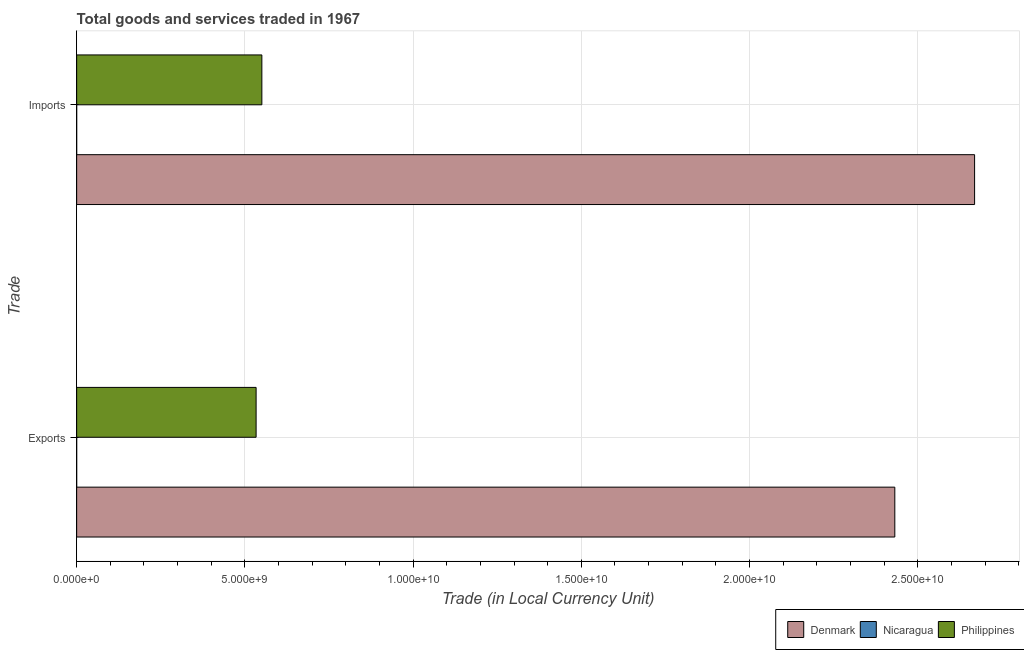How many different coloured bars are there?
Offer a very short reply. 3. Are the number of bars per tick equal to the number of legend labels?
Give a very brief answer. Yes. What is the label of the 1st group of bars from the top?
Make the answer very short. Imports. What is the export of goods and services in Philippines?
Your response must be concise. 5.33e+09. Across all countries, what is the maximum export of goods and services?
Make the answer very short. 2.43e+1. Across all countries, what is the minimum export of goods and services?
Make the answer very short. 0.24. In which country was the imports of goods and services minimum?
Provide a succinct answer. Nicaragua. What is the total imports of goods and services in the graph?
Your answer should be compact. 3.22e+1. What is the difference between the export of goods and services in Denmark and that in Philippines?
Make the answer very short. 1.90e+1. What is the difference between the export of goods and services in Denmark and the imports of goods and services in Philippines?
Make the answer very short. 1.88e+1. What is the average imports of goods and services per country?
Give a very brief answer. 1.07e+1. What is the difference between the export of goods and services and imports of goods and services in Philippines?
Make the answer very short. -1.71e+08. What is the ratio of the export of goods and services in Denmark to that in Philippines?
Give a very brief answer. 4.56. Is the export of goods and services in Denmark less than that in Nicaragua?
Make the answer very short. No. What does the 1st bar from the top in Exports represents?
Provide a succinct answer. Philippines. What does the 3rd bar from the bottom in Exports represents?
Your answer should be very brief. Philippines. Are all the bars in the graph horizontal?
Give a very brief answer. Yes. What is the difference between two consecutive major ticks on the X-axis?
Offer a terse response. 5.00e+09. Are the values on the major ticks of X-axis written in scientific E-notation?
Make the answer very short. Yes. Where does the legend appear in the graph?
Give a very brief answer. Bottom right. How many legend labels are there?
Ensure brevity in your answer.  3. How are the legend labels stacked?
Provide a succinct answer. Horizontal. What is the title of the graph?
Your answer should be compact. Total goods and services traded in 1967. Does "Benin" appear as one of the legend labels in the graph?
Keep it short and to the point. No. What is the label or title of the X-axis?
Provide a short and direct response. Trade (in Local Currency Unit). What is the label or title of the Y-axis?
Provide a succinct answer. Trade. What is the Trade (in Local Currency Unit) of Denmark in Exports?
Your answer should be very brief. 2.43e+1. What is the Trade (in Local Currency Unit) of Nicaragua in Exports?
Offer a very short reply. 0.24. What is the Trade (in Local Currency Unit) of Philippines in Exports?
Ensure brevity in your answer.  5.33e+09. What is the Trade (in Local Currency Unit) of Denmark in Imports?
Offer a very short reply. 2.67e+1. What is the Trade (in Local Currency Unit) in Nicaragua in Imports?
Your answer should be very brief. 0.32. What is the Trade (in Local Currency Unit) of Philippines in Imports?
Ensure brevity in your answer.  5.50e+09. Across all Trade, what is the maximum Trade (in Local Currency Unit) in Denmark?
Your answer should be compact. 2.67e+1. Across all Trade, what is the maximum Trade (in Local Currency Unit) of Nicaragua?
Your answer should be very brief. 0.32. Across all Trade, what is the maximum Trade (in Local Currency Unit) of Philippines?
Provide a succinct answer. 5.50e+09. Across all Trade, what is the minimum Trade (in Local Currency Unit) of Denmark?
Give a very brief answer. 2.43e+1. Across all Trade, what is the minimum Trade (in Local Currency Unit) of Nicaragua?
Your response must be concise. 0.24. Across all Trade, what is the minimum Trade (in Local Currency Unit) of Philippines?
Ensure brevity in your answer.  5.33e+09. What is the total Trade (in Local Currency Unit) in Denmark in the graph?
Offer a very short reply. 5.10e+1. What is the total Trade (in Local Currency Unit) in Nicaragua in the graph?
Offer a very short reply. 0.57. What is the total Trade (in Local Currency Unit) in Philippines in the graph?
Give a very brief answer. 1.08e+1. What is the difference between the Trade (in Local Currency Unit) of Denmark in Exports and that in Imports?
Keep it short and to the point. -2.37e+09. What is the difference between the Trade (in Local Currency Unit) in Nicaragua in Exports and that in Imports?
Provide a short and direct response. -0.08. What is the difference between the Trade (in Local Currency Unit) of Philippines in Exports and that in Imports?
Your answer should be very brief. -1.71e+08. What is the difference between the Trade (in Local Currency Unit) of Denmark in Exports and the Trade (in Local Currency Unit) of Nicaragua in Imports?
Provide a short and direct response. 2.43e+1. What is the difference between the Trade (in Local Currency Unit) of Denmark in Exports and the Trade (in Local Currency Unit) of Philippines in Imports?
Provide a succinct answer. 1.88e+1. What is the difference between the Trade (in Local Currency Unit) in Nicaragua in Exports and the Trade (in Local Currency Unit) in Philippines in Imports?
Your answer should be compact. -5.50e+09. What is the average Trade (in Local Currency Unit) of Denmark per Trade?
Give a very brief answer. 2.55e+1. What is the average Trade (in Local Currency Unit) of Nicaragua per Trade?
Provide a succinct answer. 0.28. What is the average Trade (in Local Currency Unit) of Philippines per Trade?
Offer a very short reply. 5.42e+09. What is the difference between the Trade (in Local Currency Unit) in Denmark and Trade (in Local Currency Unit) in Nicaragua in Exports?
Keep it short and to the point. 2.43e+1. What is the difference between the Trade (in Local Currency Unit) in Denmark and Trade (in Local Currency Unit) in Philippines in Exports?
Your answer should be compact. 1.90e+1. What is the difference between the Trade (in Local Currency Unit) of Nicaragua and Trade (in Local Currency Unit) of Philippines in Exports?
Make the answer very short. -5.33e+09. What is the difference between the Trade (in Local Currency Unit) of Denmark and Trade (in Local Currency Unit) of Nicaragua in Imports?
Offer a terse response. 2.67e+1. What is the difference between the Trade (in Local Currency Unit) in Denmark and Trade (in Local Currency Unit) in Philippines in Imports?
Offer a terse response. 2.12e+1. What is the difference between the Trade (in Local Currency Unit) in Nicaragua and Trade (in Local Currency Unit) in Philippines in Imports?
Keep it short and to the point. -5.50e+09. What is the ratio of the Trade (in Local Currency Unit) in Denmark in Exports to that in Imports?
Your answer should be compact. 0.91. What is the ratio of the Trade (in Local Currency Unit) in Nicaragua in Exports to that in Imports?
Offer a very short reply. 0.76. What is the ratio of the Trade (in Local Currency Unit) of Philippines in Exports to that in Imports?
Your answer should be very brief. 0.97. What is the difference between the highest and the second highest Trade (in Local Currency Unit) of Denmark?
Keep it short and to the point. 2.37e+09. What is the difference between the highest and the second highest Trade (in Local Currency Unit) of Nicaragua?
Your response must be concise. 0.08. What is the difference between the highest and the second highest Trade (in Local Currency Unit) of Philippines?
Give a very brief answer. 1.71e+08. What is the difference between the highest and the lowest Trade (in Local Currency Unit) in Denmark?
Offer a very short reply. 2.37e+09. What is the difference between the highest and the lowest Trade (in Local Currency Unit) of Nicaragua?
Your answer should be very brief. 0.08. What is the difference between the highest and the lowest Trade (in Local Currency Unit) in Philippines?
Give a very brief answer. 1.71e+08. 